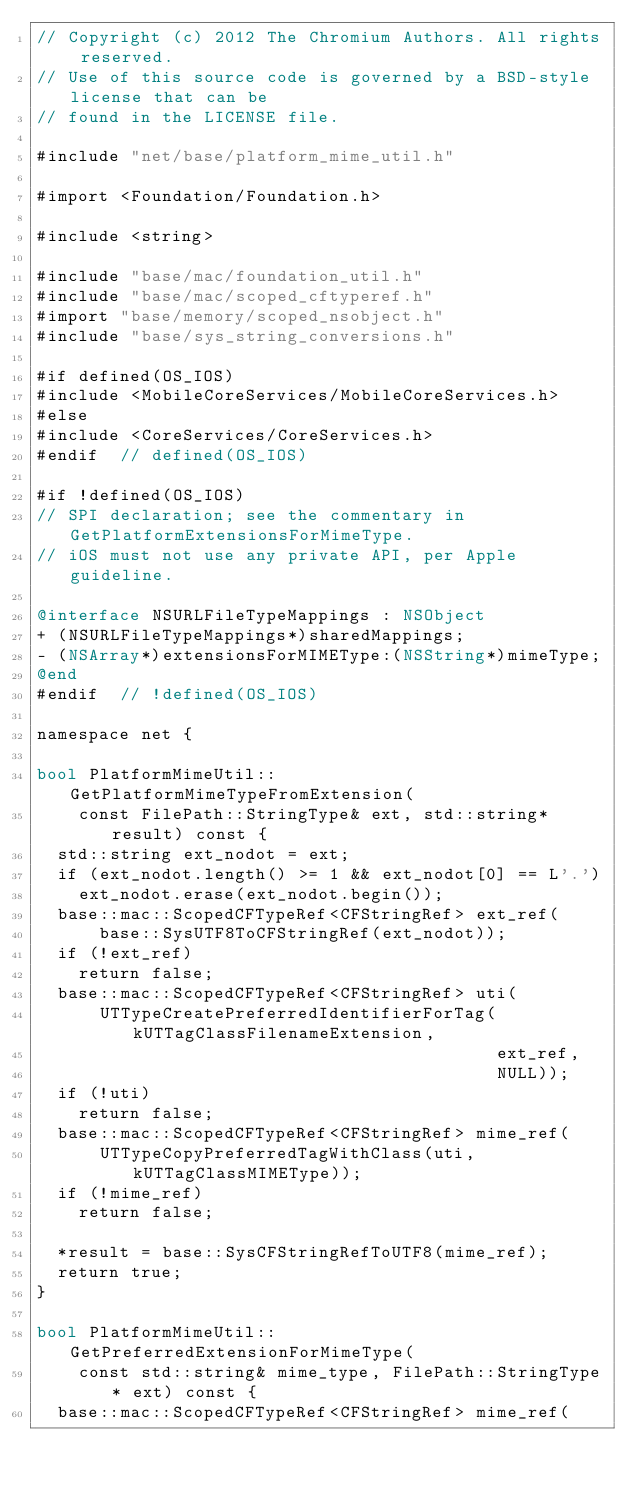Convert code to text. <code><loc_0><loc_0><loc_500><loc_500><_ObjectiveC_>// Copyright (c) 2012 The Chromium Authors. All rights reserved.
// Use of this source code is governed by a BSD-style license that can be
// found in the LICENSE file.

#include "net/base/platform_mime_util.h"

#import <Foundation/Foundation.h>

#include <string>

#include "base/mac/foundation_util.h"
#include "base/mac/scoped_cftyperef.h"
#import "base/memory/scoped_nsobject.h"
#include "base/sys_string_conversions.h"

#if defined(OS_IOS)
#include <MobileCoreServices/MobileCoreServices.h>
#else
#include <CoreServices/CoreServices.h>
#endif  // defined(OS_IOS)

#if !defined(OS_IOS)
// SPI declaration; see the commentary in GetPlatformExtensionsForMimeType.
// iOS must not use any private API, per Apple guideline.

@interface NSURLFileTypeMappings : NSObject
+ (NSURLFileTypeMappings*)sharedMappings;
- (NSArray*)extensionsForMIMEType:(NSString*)mimeType;
@end
#endif  // !defined(OS_IOS)

namespace net {

bool PlatformMimeUtil::GetPlatformMimeTypeFromExtension(
    const FilePath::StringType& ext, std::string* result) const {
  std::string ext_nodot = ext;
  if (ext_nodot.length() >= 1 && ext_nodot[0] == L'.')
    ext_nodot.erase(ext_nodot.begin());
  base::mac::ScopedCFTypeRef<CFStringRef> ext_ref(
      base::SysUTF8ToCFStringRef(ext_nodot));
  if (!ext_ref)
    return false;
  base::mac::ScopedCFTypeRef<CFStringRef> uti(
      UTTypeCreatePreferredIdentifierForTag(kUTTagClassFilenameExtension,
                                            ext_ref,
                                            NULL));
  if (!uti)
    return false;
  base::mac::ScopedCFTypeRef<CFStringRef> mime_ref(
      UTTypeCopyPreferredTagWithClass(uti, kUTTagClassMIMEType));
  if (!mime_ref)
    return false;

  *result = base::SysCFStringRefToUTF8(mime_ref);
  return true;
}

bool PlatformMimeUtil::GetPreferredExtensionForMimeType(
    const std::string& mime_type, FilePath::StringType* ext) const {
  base::mac::ScopedCFTypeRef<CFStringRef> mime_ref(</code> 